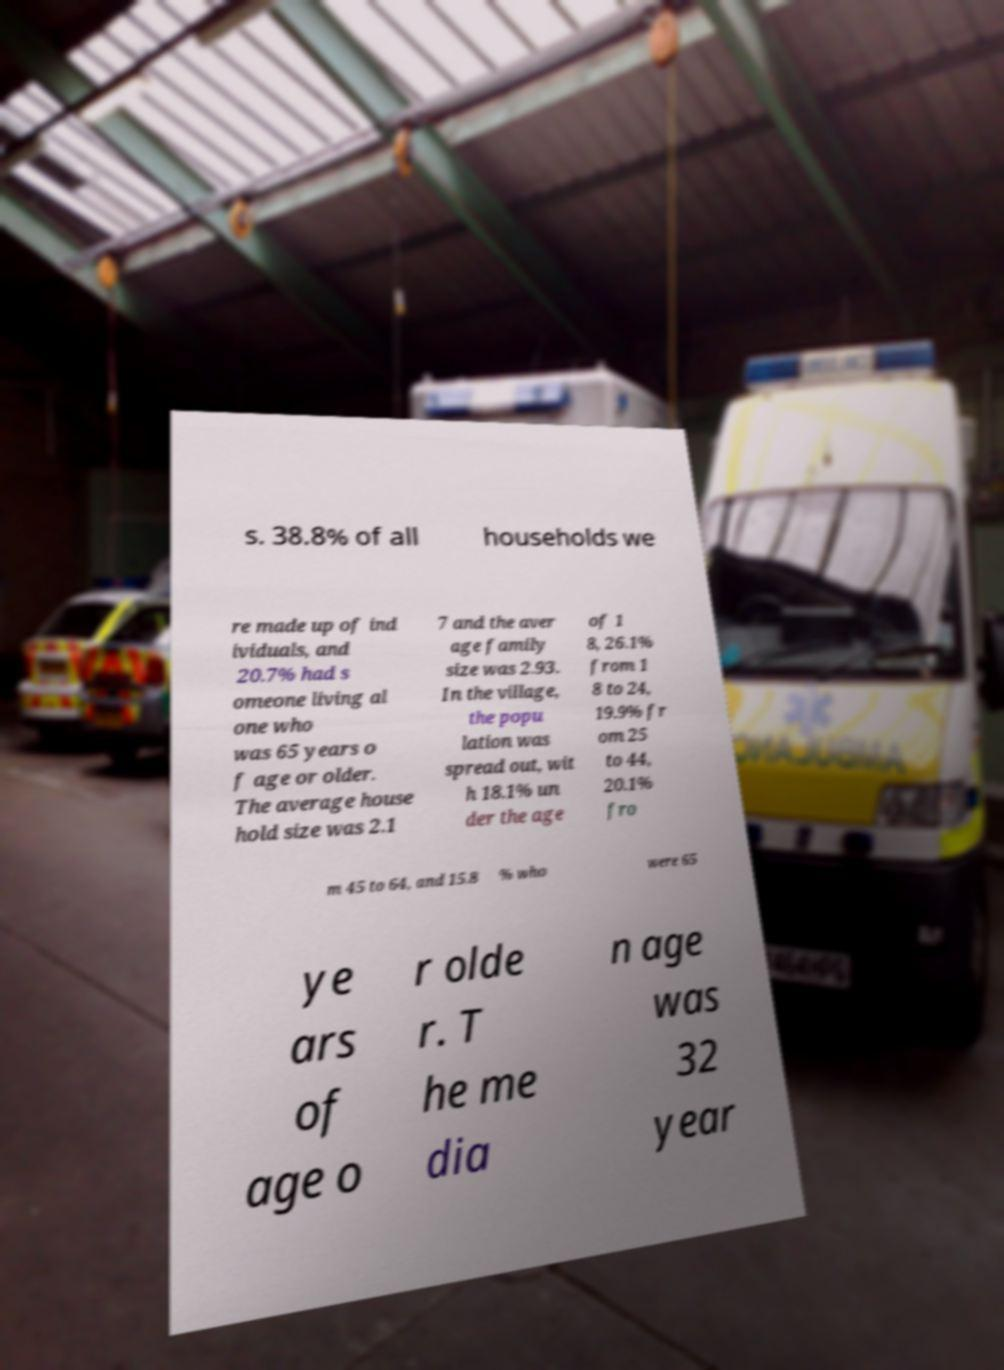Can you accurately transcribe the text from the provided image for me? s. 38.8% of all households we re made up of ind ividuals, and 20.7% had s omeone living al one who was 65 years o f age or older. The average house hold size was 2.1 7 and the aver age family size was 2.93. In the village, the popu lation was spread out, wit h 18.1% un der the age of 1 8, 26.1% from 1 8 to 24, 19.9% fr om 25 to 44, 20.1% fro m 45 to 64, and 15.8 % who were 65 ye ars of age o r olde r. T he me dia n age was 32 year 